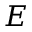<formula> <loc_0><loc_0><loc_500><loc_500>E</formula> 